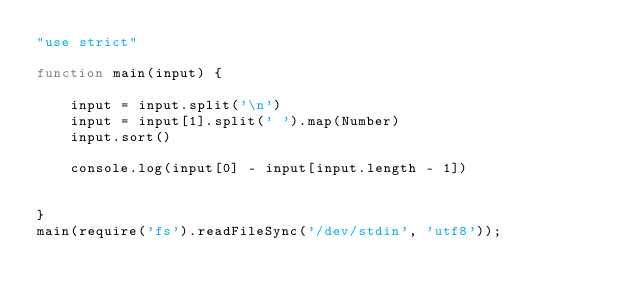<code> <loc_0><loc_0><loc_500><loc_500><_JavaScript_>"use strict"

function main(input) {

    input = input.split('\n')
    input = input[1].split(' ').map(Number)
    input.sort()

    console.log(input[0] - input[input.length - 1])


}
main(require('fs').readFileSync('/dev/stdin', 'utf8'));</code> 